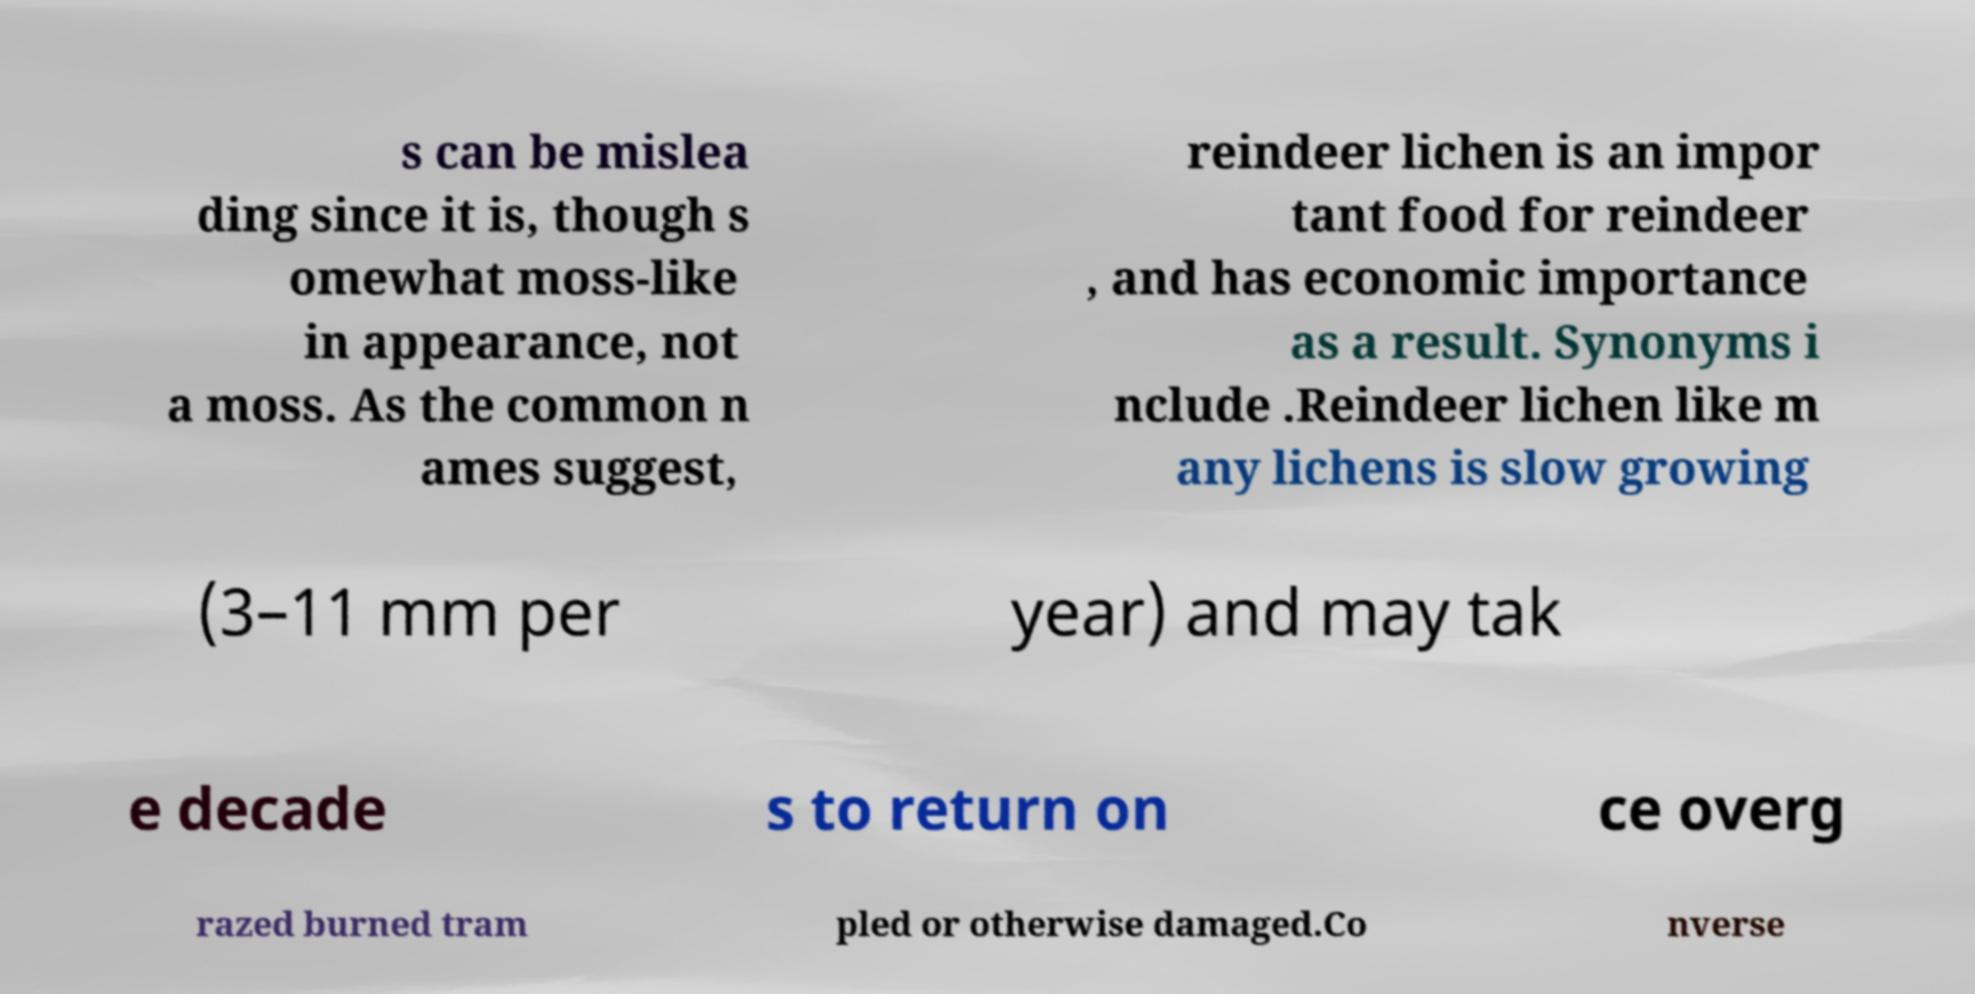What messages or text are displayed in this image? I need them in a readable, typed format. s can be mislea ding since it is, though s omewhat moss-like in appearance, not a moss. As the common n ames suggest, reindeer lichen is an impor tant food for reindeer , and has economic importance as a result. Synonyms i nclude .Reindeer lichen like m any lichens is slow growing (3–11 mm per year) and may tak e decade s to return on ce overg razed burned tram pled or otherwise damaged.Co nverse 